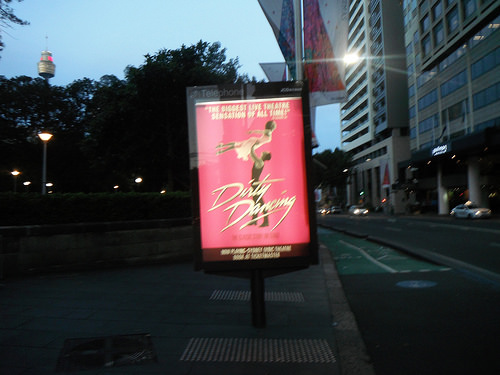<image>
Can you confirm if the car is in the road? Yes. The car is contained within or inside the road, showing a containment relationship. 